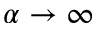Convert formula to latex. <formula><loc_0><loc_0><loc_500><loc_500>\alpha \to \infty</formula> 